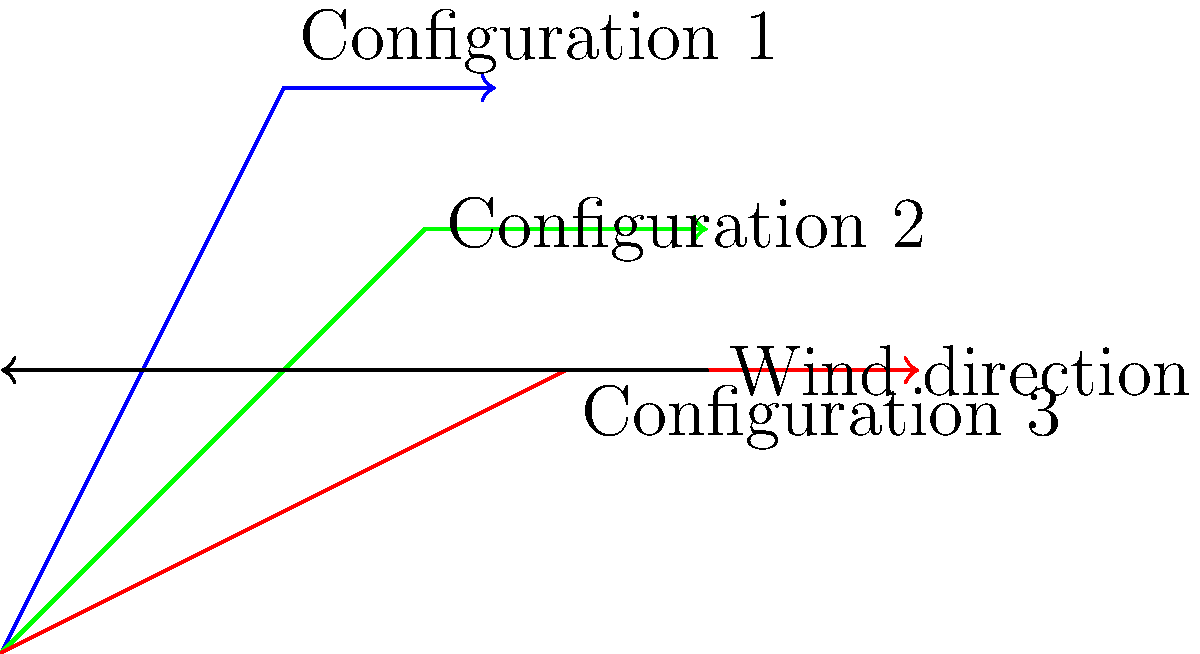As a yacht enthusiast observing different sail configurations, you notice three distinct setups represented in the vector diagram. Which sail configuration experiences the greatest wind force, and how does this relate to the sail's angle relative to the wind direction? To determine which sail configuration experiences the greatest wind force, we need to analyze the vector diagram and consider the relationship between sail angle and wind direction:

1. Configuration 1 (blue): The sail is at the steepest angle relative to the wind direction. The wind force vector is the shortest, indicating the least force.

2. Configuration 2 (green): The sail is at an intermediate angle. The wind force vector is longer than Configuration 1 but shorter than Configuration 3.

3. Configuration 3 (red): The sail is at the shallowest angle relative to the wind direction. The wind force vector is the longest, indicating the greatest force.

The relationship between sail angle and wind force can be explained by the concept of projected area:

1. When a sail is perpendicular to the wind (steep angle), it presents a smaller projected area to the wind, resulting in less force.

2. As the sail angle becomes more parallel to the wind direction, its projected area increases, leading to greater wind force.

3. The force on the sail is proportional to the projected area, which is why Configuration 3 experiences the greatest wind force.

This relationship is described by the equation:

$$ F = \frac{1}{2} \rho v^2 C_D A \cos\theta $$

Where:
$F$ = wind force
$\rho$ = air density
$v$ = wind velocity
$C_D$ = drag coefficient
$A$ = sail area
$\theta$ = angle between the wind direction and the sail

As $\theta$ decreases (sail becomes more parallel to wind), $\cos\theta$ increases, resulting in a greater force $F$.
Answer: Configuration 3 (red) experiences the greatest wind force due to its shallow angle relative to the wind direction, maximizing projected area. 